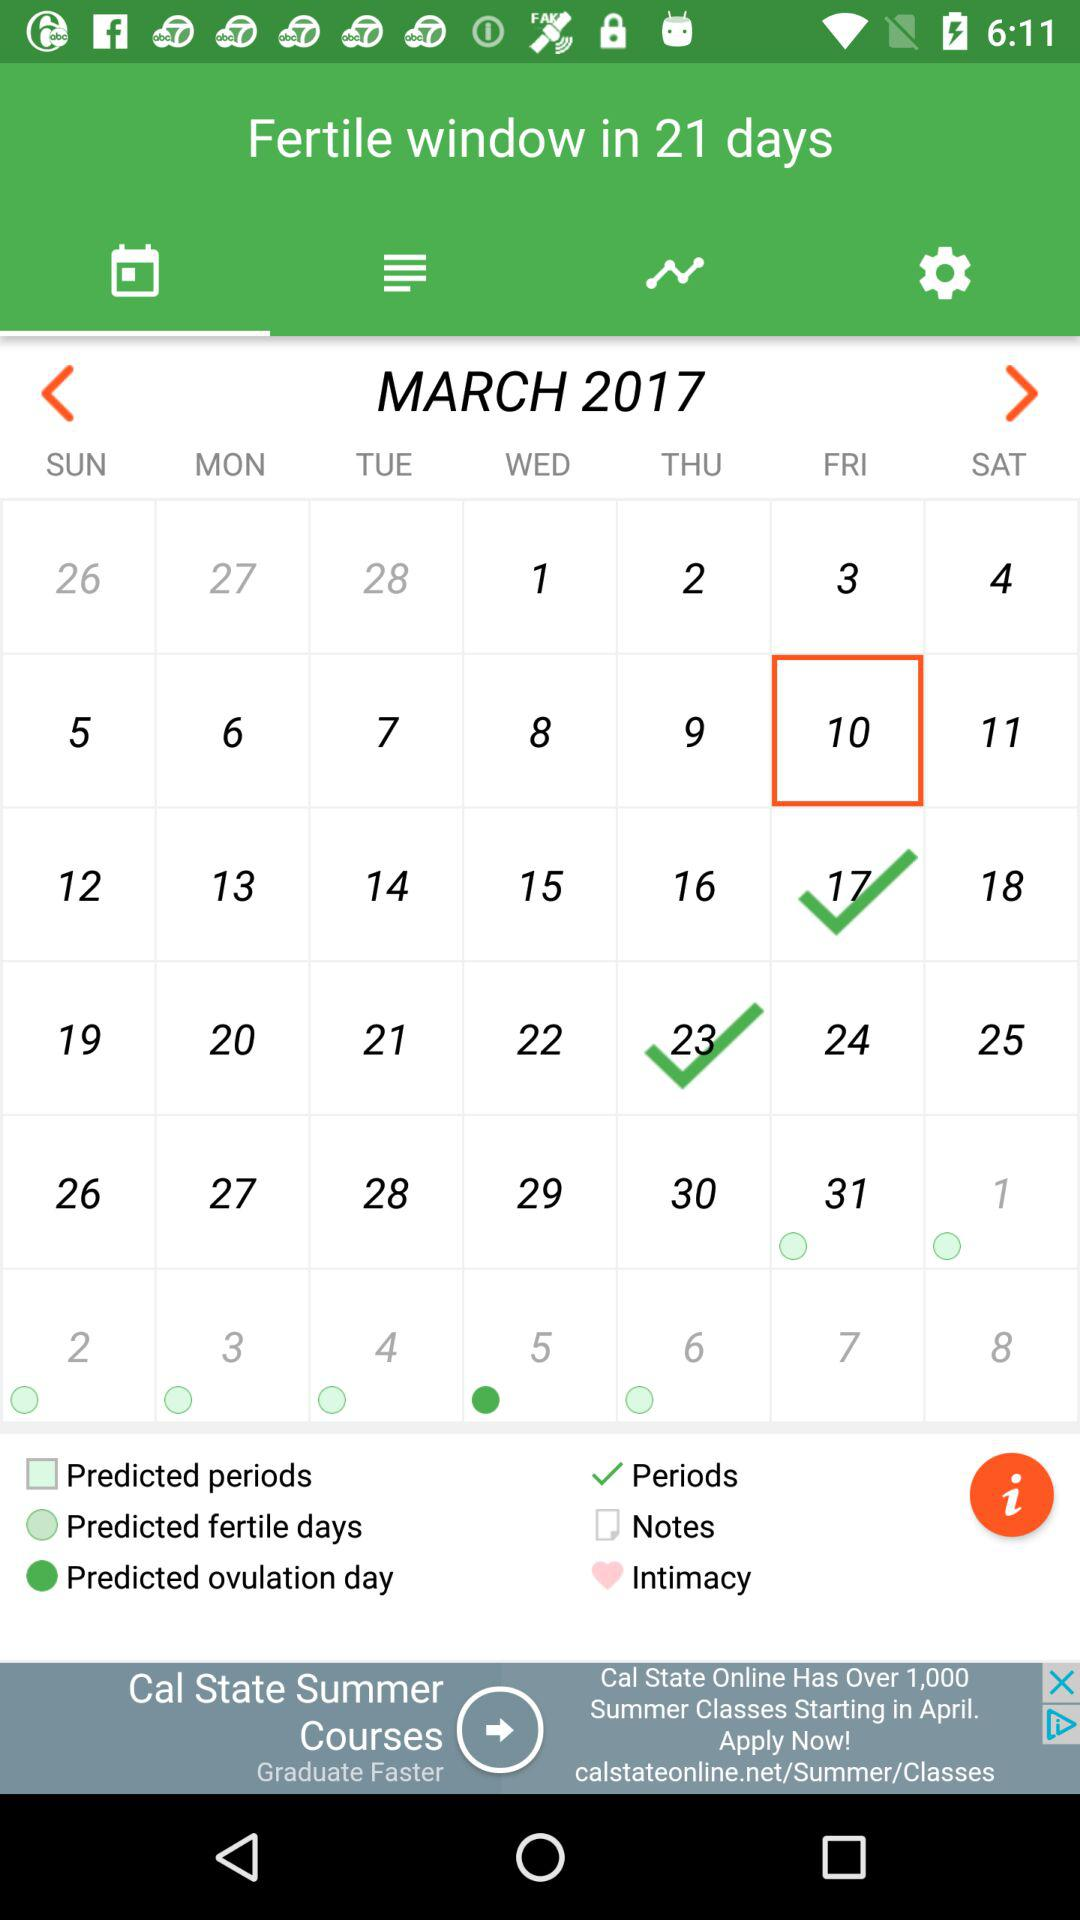Which are the period days? The period days are from Friday, March 17, 2017 to Thursday, March 23, 2017. 